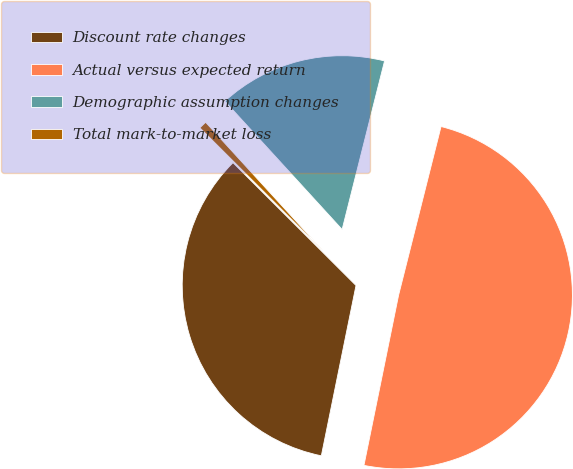Convert chart to OTSL. <chart><loc_0><loc_0><loc_500><loc_500><pie_chart><fcel>Discount rate changes<fcel>Actual versus expected return<fcel>Demographic assumption changes<fcel>Total mark-to-market loss<nl><fcel>34.29%<fcel>49.27%<fcel>15.71%<fcel>0.73%<nl></chart> 